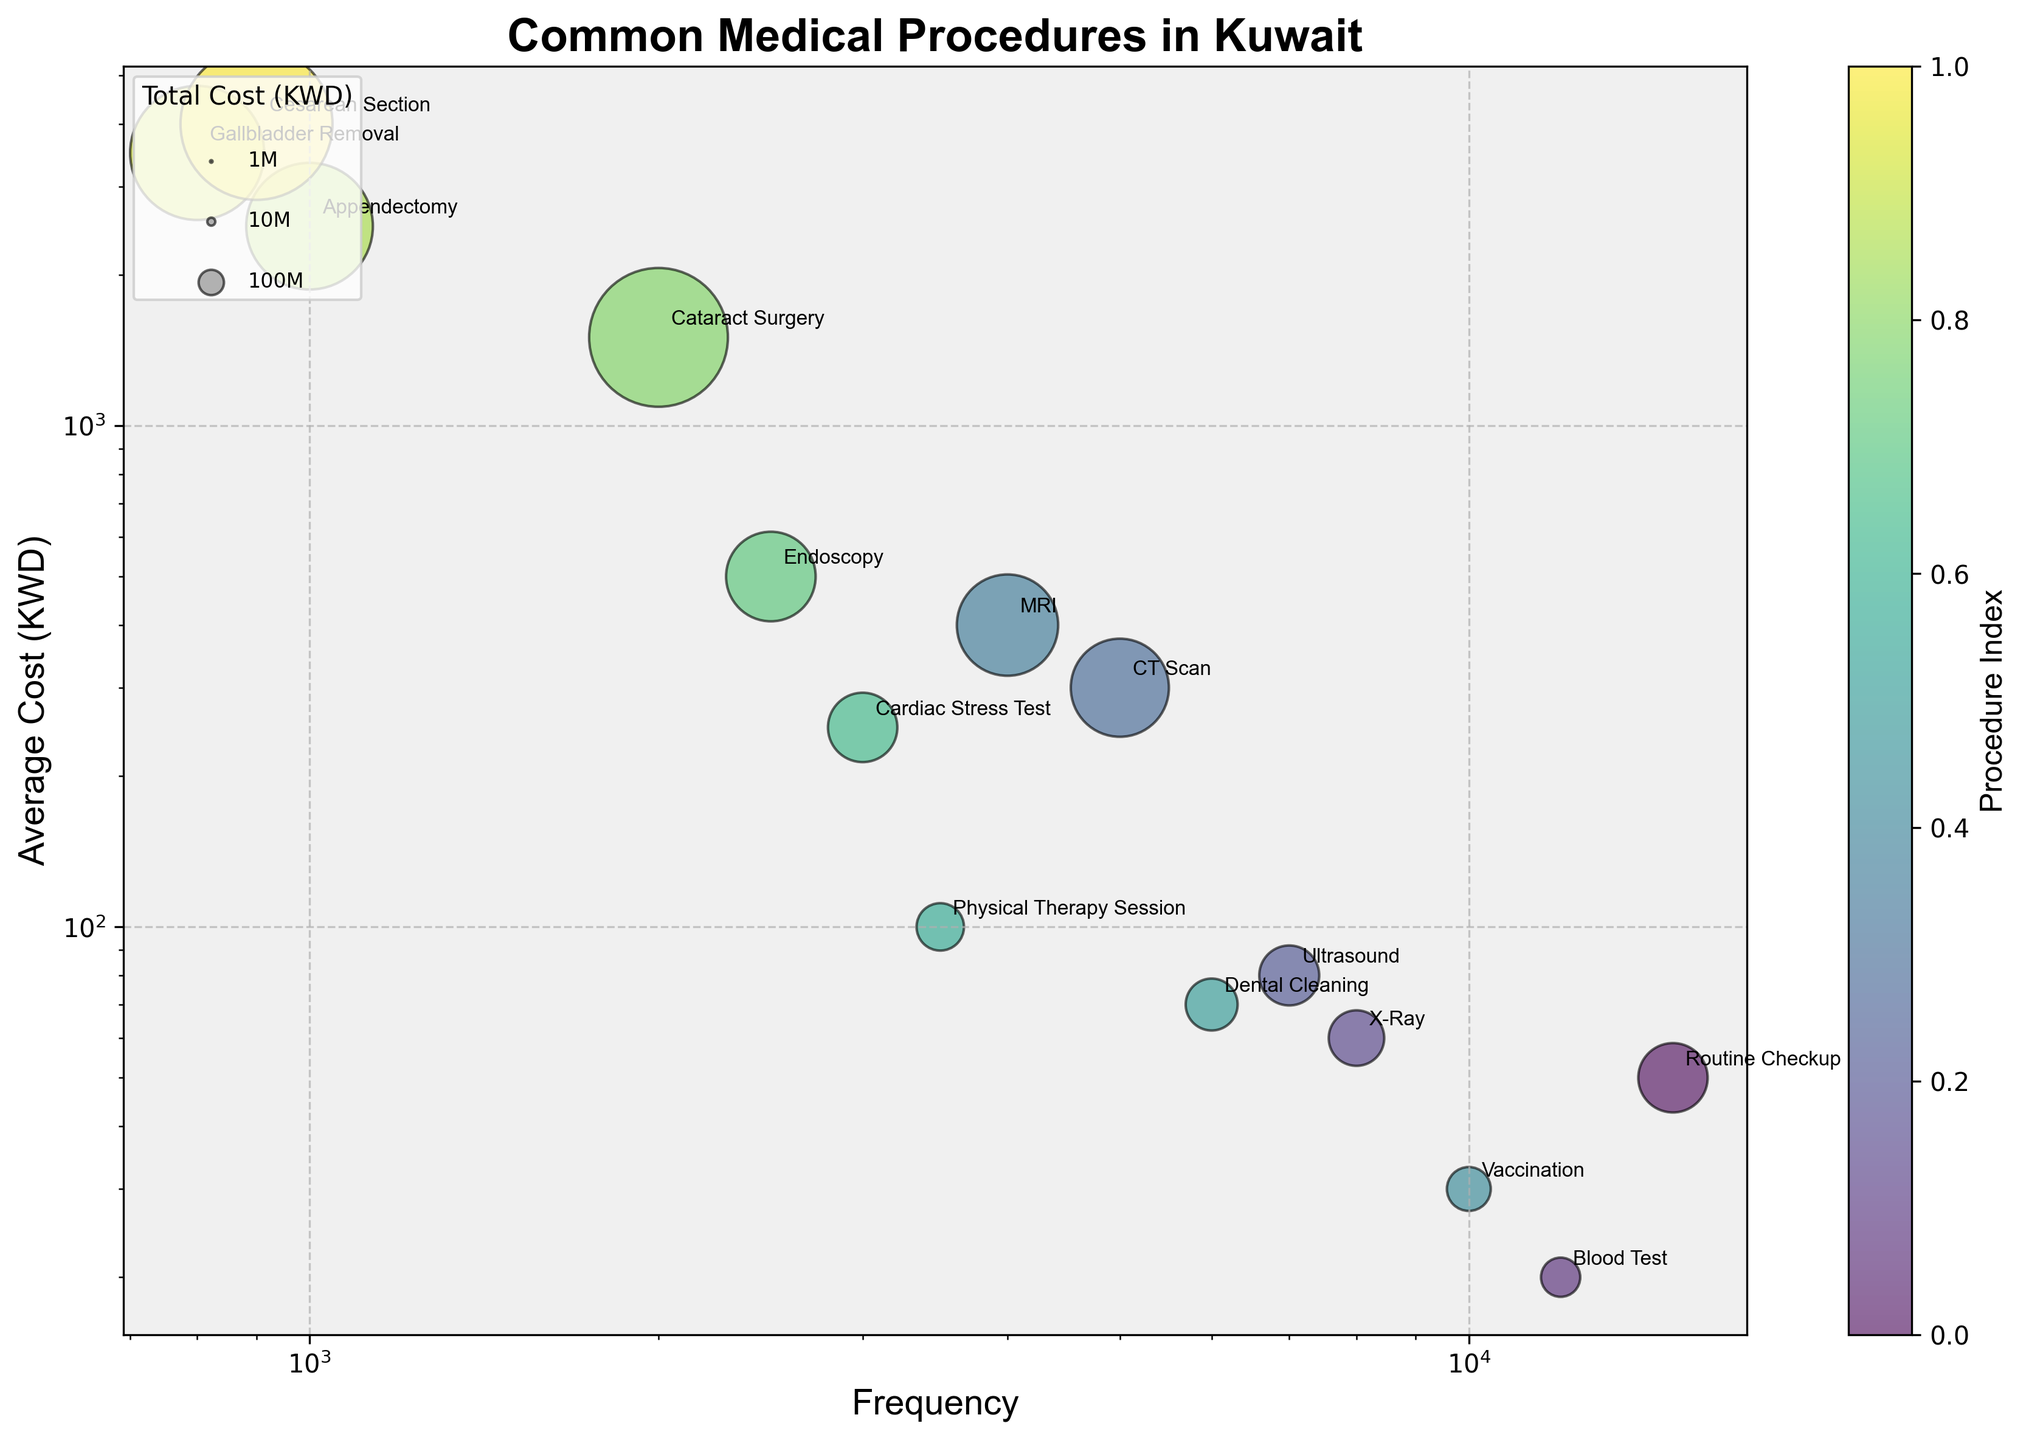Which procedure has the highest average cost? By observing the vertical axis which represents the average cost and identifying the highest point, the procedure with the highest average cost can be found. Cataract Surgery has an average cost of 1500, while Appendectomy costs 2500, Gallbladder Removal costs 3500, and Cesarean Section is the highest at 4000.
Answer: Cesarean Section Which procedure is the most frequent? Looking at the horizontal axis which represents the frequency and identifying the farthest point to the right, the procedure with the highest frequency is identified. Routine Checkup has the highest frequency of 15000.
Answer: Routine Checkup What is the relationship between frequency and average cost for an MRI compared to a CT Scan? By comparing the x-coordinates (frequencies) and y-coordinates (average costs) of both MRI and CT Scan bubbles - MRI has a lower frequency but higher average cost than the CT Scan. MRI has 4000 frequency and 400 average cost while CT Scan has 5000 frequency and 300 average cost.
Answer: MRI has a lower frequency but higher average cost than CT Scan What is the average cost of the least frequent procedure? Find the procedure with the lowest frequency on the horizontal axis, which is Gallbladder Removal with a frequency of 800. Then check its corresponding average cost on the vertical axis.
Answer: 3500 How does the size of the bubble for Cesarean Section compare to that for Vaccination? The size of the bubble is proportional to the total cost (frequency multiplied by average cost). Cesarean Section has a larger bubble compared to Vaccination because its total cost is higher. Cesarean Section’s total cost is 900 * 4000 = 3,600,000, while Vaccination’s total cost is 10000 * 30 = 300,000.
Answer: Cesarean Section’s bubble is much larger How many procedures have an average cost greater than 1000 KWD? By observing the vertical axis and counting all bubbles above the 1000 KWD mark, the procedures can be identified: Endoscopy, Cataract Surgery, Appendectomy, Gallbladder Removal, and Cesarean Section.
Answer: 5 Which procedure has the smallest bubble size? Bubbles' sizes are proportional to the product of frequency and average cost. By identifying the smallest bubble visually, Physical Therapy Session fits this since it has lower values compared to others like Cesarean Section or Routine Checkup.
Answer: Physical Therapy Session Are there any procedures that appear close together in frequency but differ significantly in average cost? By looking at bubbles horizontally aligned but with different heights, CT Scan and Cardiac Stress Test are close at 5000 and 3000 respectively but differ significantly in cost (300 vs 250 KWD).
Answer: CT Scan and Cardiac Stress Test 